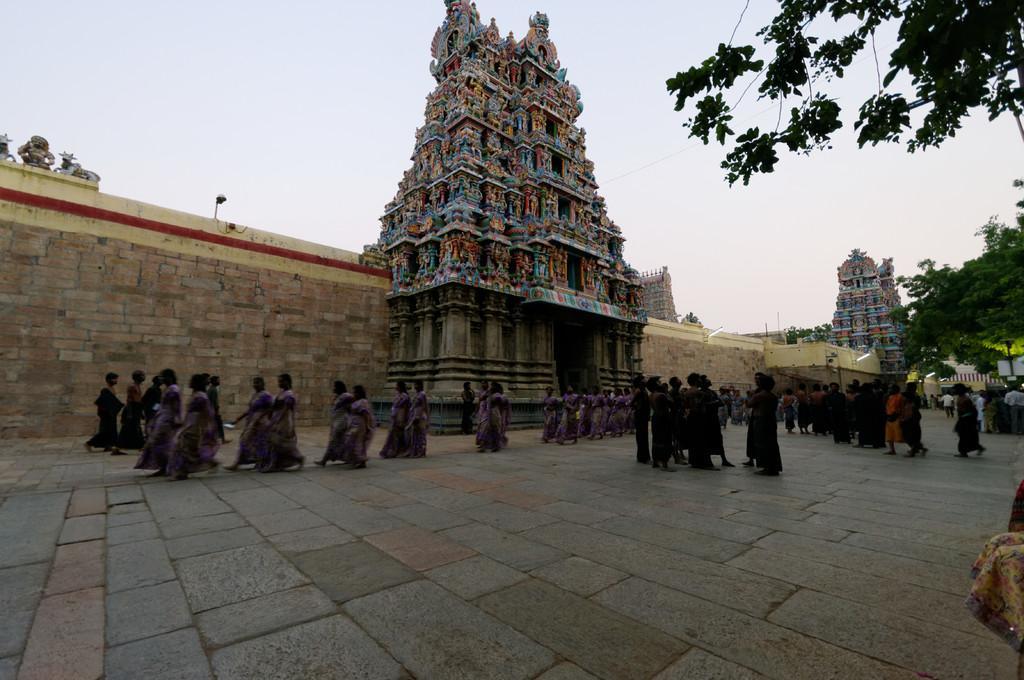Could you give a brief overview of what you see in this image? In this image we can see a temple with lights and statues. We can also see a wall and a group of people standing on the floor. On the backside we can see a tree and the sky which looks cloudy. 